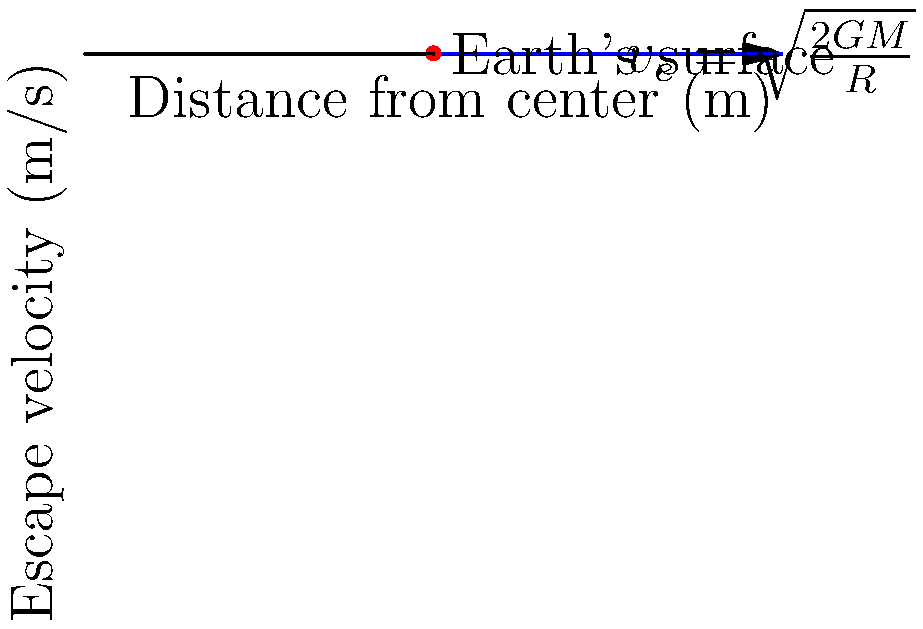As a scholar studying pre-space age rocketry history, you're analyzing early calculations of escape velocities. Using the graph provided, which shows the relationship between escape velocity and distance from the center of Earth, determine the escape velocity at Earth's surface. Given that Earth's mass is $5.97 \times 10^{24}$ kg and its radius is $6.37 \times 10^6$ m, verify the graphical result using the escape velocity equation. To solve this problem, we'll follow these steps:

1. Identify the escape velocity from the graph:
   From the graph, we can see that the escape velocity at Earth's surface (where r = R) is approximately 11,200 m/s.

2. Verify this result using the escape velocity equation:
   The escape velocity equation is given by:

   $$v_e = \sqrt{\frac{2GM}{R}}$$

   where:
   $v_e$ is the escape velocity
   $G$ is the gravitational constant ($6.67 \times 10^{-11}$ N⋅m²/kg²)
   $M$ is the mass of Earth ($5.97 \times 10^{24}$ kg)
   $R$ is the radius of Earth ($6.37 \times 10^6$ m)

3. Substitute the values into the equation:

   $$v_e = \sqrt{\frac{2 \times (6.67 \times 10^{-11}) \times (5.97 \times 10^{24})}{6.37 \times 10^6}}$$

4. Calculate the result:

   $$v_e = \sqrt{1.26 \times 10^8}$$
   $$v_e \approx 11,186 \text{ m/s}$$

5. Compare the calculated result with the graphical result:
   The calculated value (11,186 m/s) closely matches the value observed on the graph (approximately 11,200 m/s), confirming the accuracy of both the graph and the calculation.
Answer: 11,186 m/s 